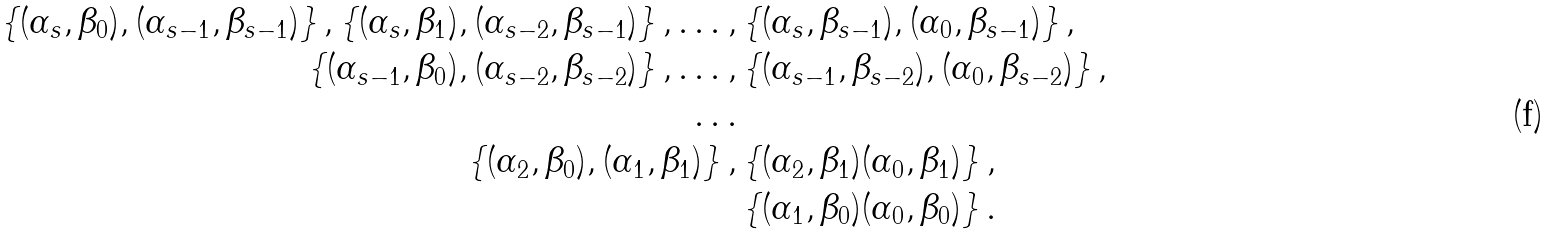Convert formula to latex. <formula><loc_0><loc_0><loc_500><loc_500>\left \{ ( \alpha _ { s } , \beta _ { 0 } ) , ( \alpha _ { s - 1 } , \beta _ { s - 1 } ) \right \} , \left \{ ( \alpha _ { s } , \beta _ { 1 } ) , ( \alpha _ { s - 2 } , \beta _ { s - 1 } ) \right \} , \dots , & \left \{ ( \alpha _ { s } , \beta _ { s - 1 } ) , ( \alpha _ { 0 } , \beta _ { s - 1 } ) \right \} , \\ \left \{ ( \alpha _ { s - 1 } , \beta _ { 0 } ) , ( \alpha _ { s - 2 } , \beta _ { s - 2 } ) \right \} , \dots , & \left \{ ( \alpha _ { s - 1 } , \beta _ { s - 2 } ) , ( \alpha _ { 0 } , \beta _ { s - 2 } ) \right \} , \\ \dots \\ \left \{ ( \alpha _ { 2 } , \beta _ { 0 } ) , ( \alpha _ { 1 } , \beta _ { 1 } ) \right \} , & \left \{ ( \alpha _ { 2 } , \beta _ { 1 } ) ( \alpha _ { 0 } , \beta _ { 1 } ) \right \} , \\ & \left \{ ( \alpha _ { 1 } , \beta _ { 0 } ) ( \alpha _ { 0 } , \beta _ { 0 } ) \right \} .</formula> 